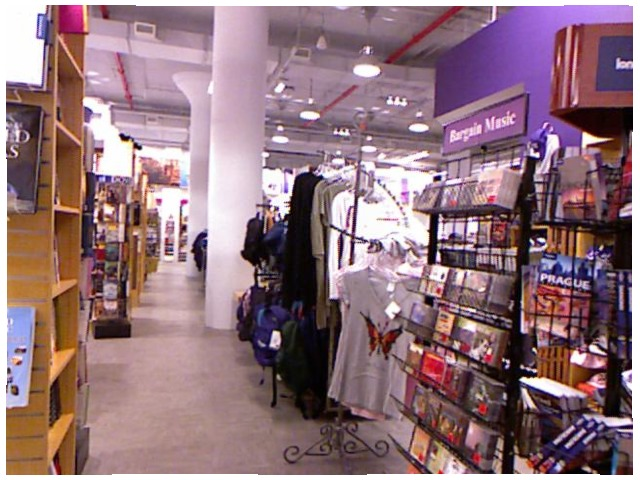<image>
Can you confirm if the pillar is in front of the cloth? No. The pillar is not in front of the cloth. The spatial positioning shows a different relationship between these objects. Where is the butterfly in relation to the shirt? Is it on the shirt? Yes. Looking at the image, I can see the butterfly is positioned on top of the shirt, with the shirt providing support. 